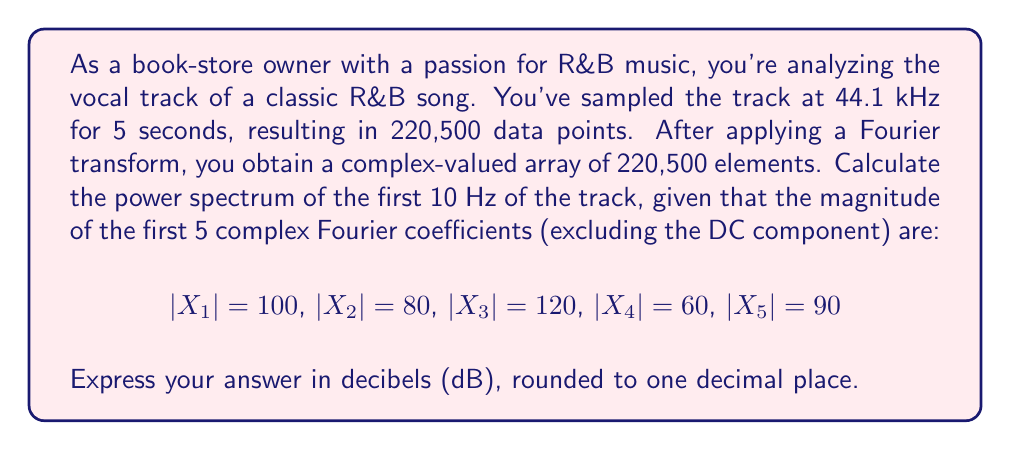Provide a solution to this math problem. To solve this problem, we need to follow these steps:

1) The power spectrum is calculated as the square of the magnitude of the Fourier coefficients.

2) For a signal of length N sampled at frequency $f_s$, the frequency resolution is given by:

   $\Delta f = \frac{f_s}{N} = \frac{44100}{220500} = 0.2$ Hz

3) Therefore, the first 5 coefficients (excluding DC) represent the frequencies:
   0.2 Hz, 0.4 Hz, 0.6 Hz, 0.8 Hz, and 1.0 Hz

4) The power spectrum for these frequencies is:

   $P_1 = |X_1|^2 = 100^2 = 10000$
   $P_2 = |X_2|^2 = 80^2 = 6400$
   $P_3 = |X_3|^2 = 120^2 = 14400$
   $P_4 = |X_4|^2 = 60^2 = 3600$
   $P_5 = |X_5|^2 = 90^2 = 8100$

5) To convert to decibels, we use the formula:

   $P_{dB} = 10 \log_{10}(P)$

6) Applying this to our power spectrum:

   $P_{1,dB} = 10 \log_{10}(10000) = 40.0$ dB
   $P_{2,dB} = 10 \log_{10}(6400) \approx 38.1$ dB
   $P_{3,dB} = 10 \log_{10}(14400) \approx 41.6$ dB
   $P_{4,dB} = 10 \log_{10}(3600) \approx 35.6$ dB
   $P_{5,dB} = 10 \log_{10}(8100) \approx 39.1$ dB

These values represent the power spectrum for the first 1 Hz of the track. To get the full 10 Hz, we would need the magnitudes of the first 50 Fourier coefficients.
Answer: The power spectrum for the first 1 Hz of the R&B vocal track, in decibels (rounded to one decimal place):

0.2 Hz: 40.0 dB
0.4 Hz: 38.1 dB
0.6 Hz: 41.6 dB
0.8 Hz: 35.6 dB
1.0 Hz: 39.1 dB 